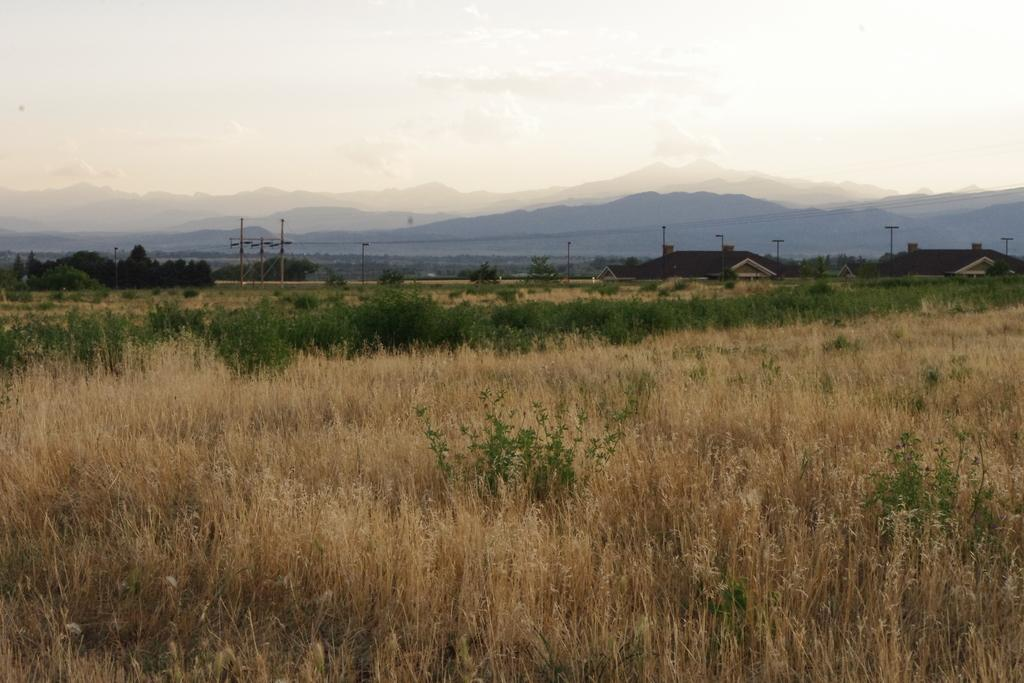What type of vegetation can be seen in the image? There is dried grass in the image. What structures are visible in the background of the image? There are sheds and poles in the background of the image. What type of trees can be seen in the background of the image? There are green trees in the background of the image. What is visible in the sky in the image? There are clouds visible in the sky. What part of the natural environment is visible in the image? The sky is visible in the background of the image. What grade is the student receiving in the image? There is no student or grade present in the image. What type of zinc can be seen in the image? There is no zinc present in the image. 